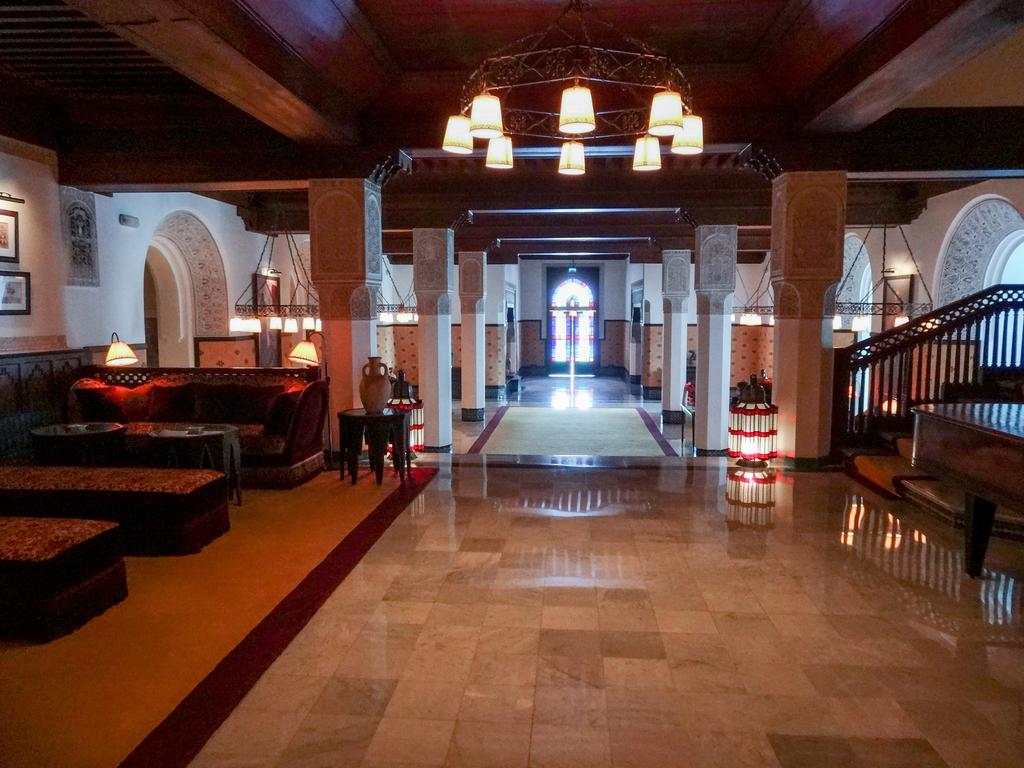What type of room is shown in the image? The image shows an inner view of a house. What piece of furniture is present in the room? There is a sofa bed in the image. What other furniture can be seen in the room? There is a table in the image. What can be used for illumination in the room? There are lights visible in the image. How many toes are visible on the bell in the image? There is no bell present in the image, and therefore no toes can be seen on it. 